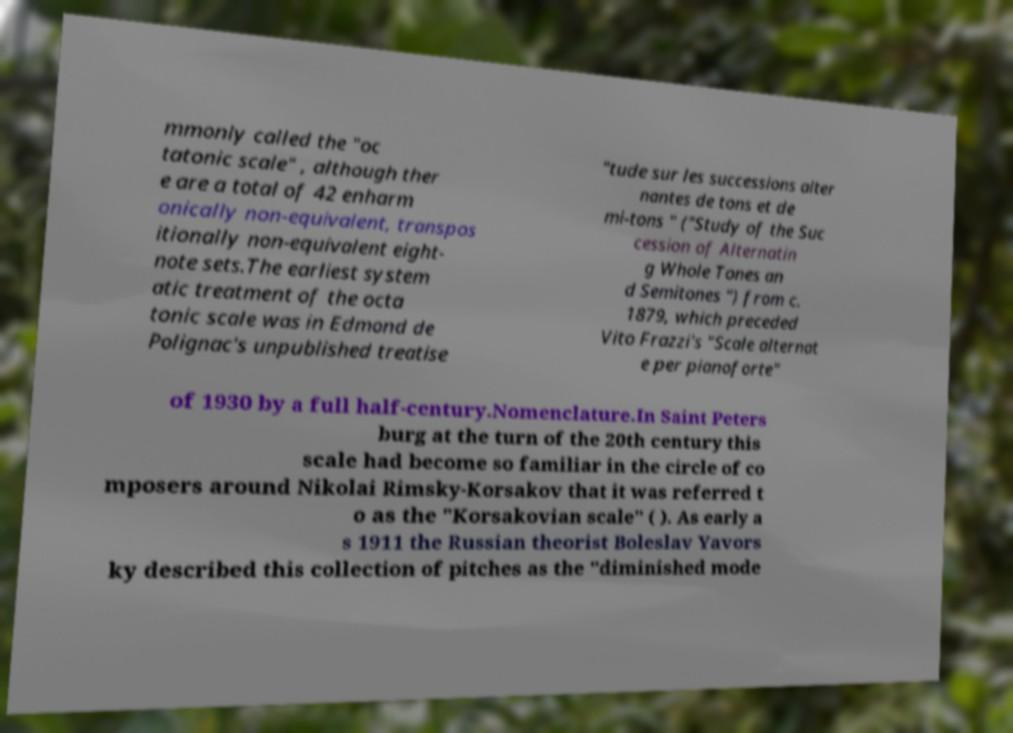Can you read and provide the text displayed in the image?This photo seems to have some interesting text. Can you extract and type it out for me? mmonly called the "oc tatonic scale" , although ther e are a total of 42 enharm onically non-equivalent, transpos itionally non-equivalent eight- note sets.The earliest system atic treatment of the octa tonic scale was in Edmond de Polignac's unpublished treatise "tude sur les successions alter nantes de tons et de mi-tons " ("Study of the Suc cession of Alternatin g Whole Tones an d Semitones ") from c. 1879, which preceded Vito Frazzi's "Scale alternat e per pianoforte" of 1930 by a full half-century.Nomenclature.In Saint Peters burg at the turn of the 20th century this scale had become so familiar in the circle of co mposers around Nikolai Rimsky-Korsakov that it was referred t o as the "Korsakovian scale" ( ). As early a s 1911 the Russian theorist Boleslav Yavors ky described this collection of pitches as the "diminished mode 